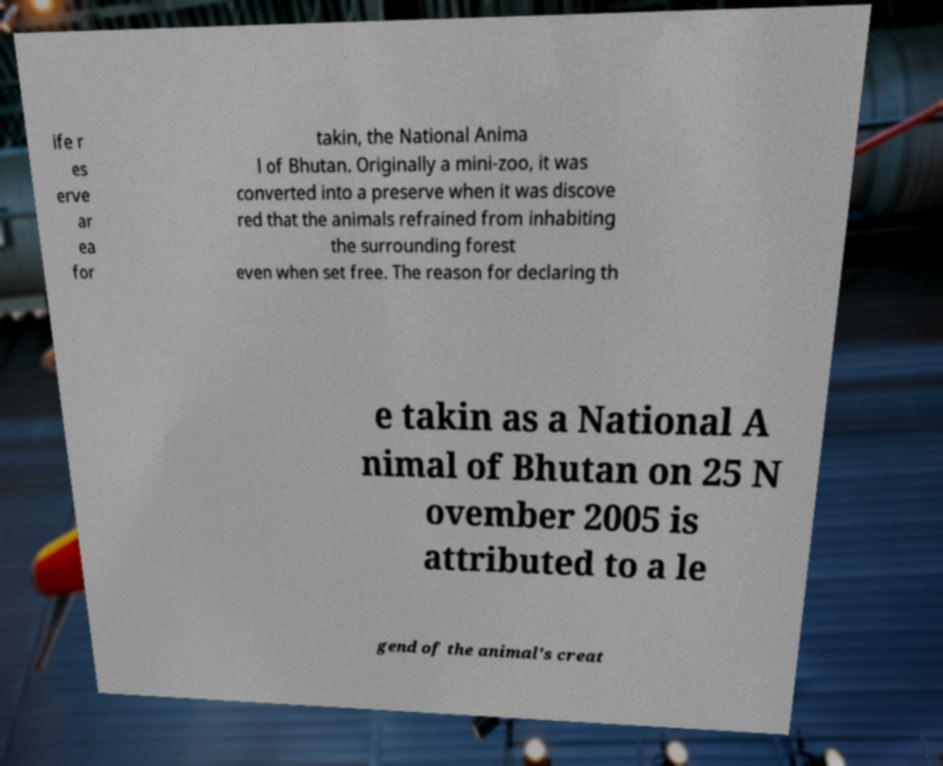For documentation purposes, I need the text within this image transcribed. Could you provide that? ife r es erve ar ea for takin, the National Anima l of Bhutan. Originally a mini-zoo, it was converted into a preserve when it was discove red that the animals refrained from inhabiting the surrounding forest even when set free. The reason for declaring th e takin as a National A nimal of Bhutan on 25 N ovember 2005 is attributed to a le gend of the animal's creat 